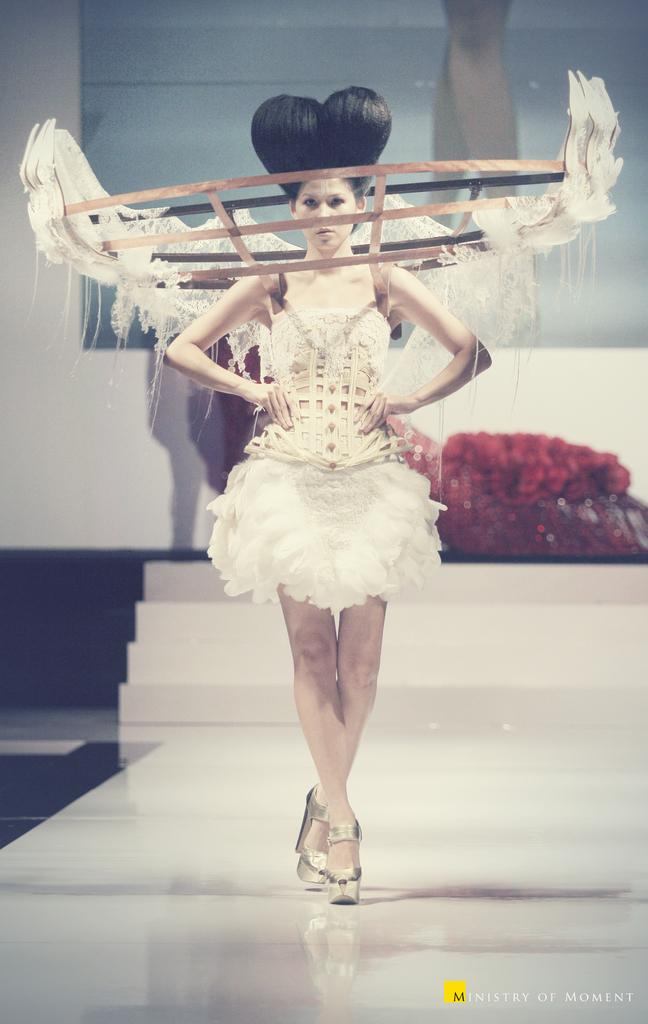Who is the main subject in the image? There is a woman in the image. What is the woman doing in the image? The woman is walking on a ramp. What is located behind the woman? There are steps behind the woman. What can be seen in the background of the image? There is a wall in the background of the image. Where is the text located in the image? The text is in the bottom right corner of the image. What type of honey is being used by the woman in the image? There is no honey present in the image; the woman is walking on a ramp. How does the woman stretch her arm in the image? The woman is not stretching her arm in the image; she is walking on a ramp. 